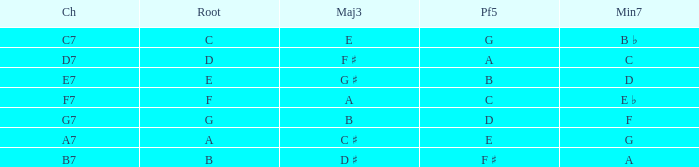What is the Chord with a Major that is third of e? C7. 